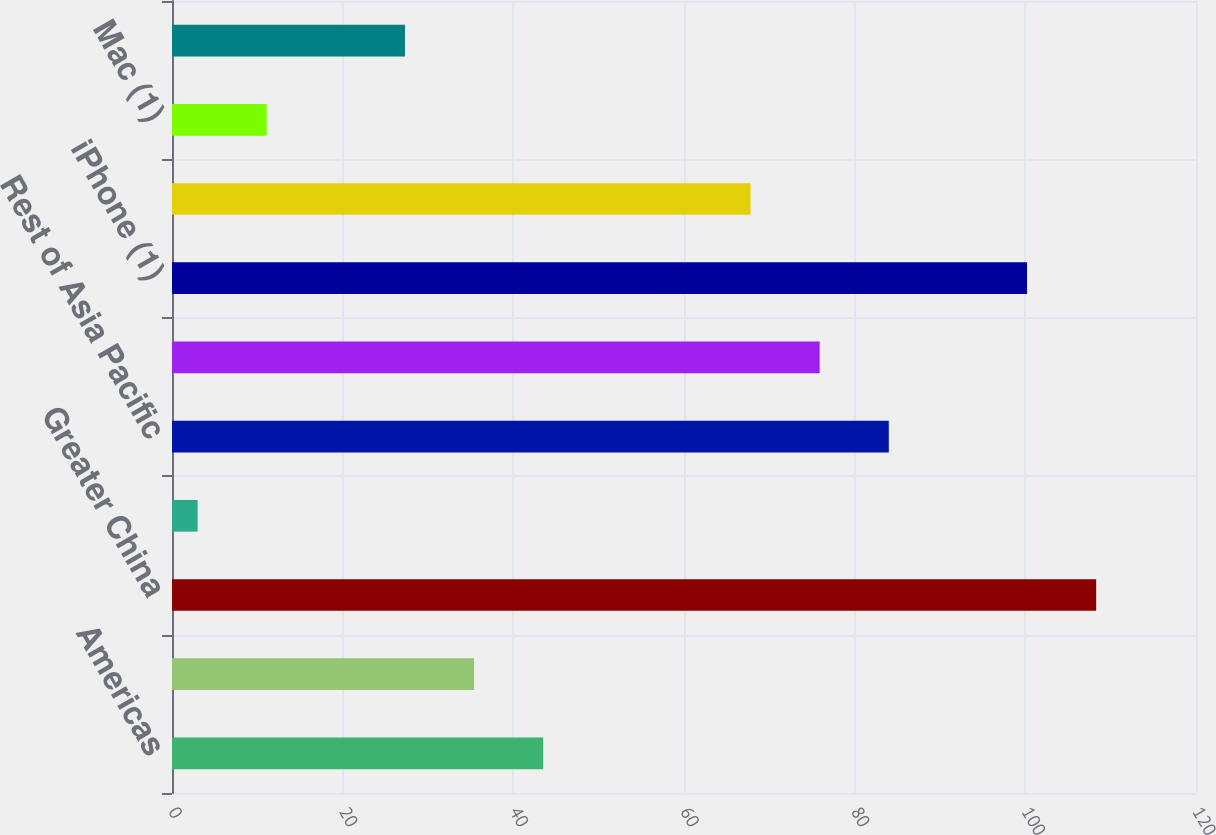<chart> <loc_0><loc_0><loc_500><loc_500><bar_chart><fcel>Americas<fcel>Europe<fcel>Greater China<fcel>Japan<fcel>Rest of Asia Pacific<fcel>Total net sales<fcel>iPhone (1)<fcel>iPad (1)<fcel>Mac (1)<fcel>Services (2)<nl><fcel>43.5<fcel>35.4<fcel>108.3<fcel>3<fcel>84<fcel>75.9<fcel>100.2<fcel>67.8<fcel>11.1<fcel>27.3<nl></chart> 